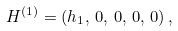<formula> <loc_0><loc_0><loc_500><loc_500>H ^ { ( 1 ) } = ( h _ { 1 } , \, 0 , \, 0 , \, 0 , \, 0 ) \, ,</formula> 